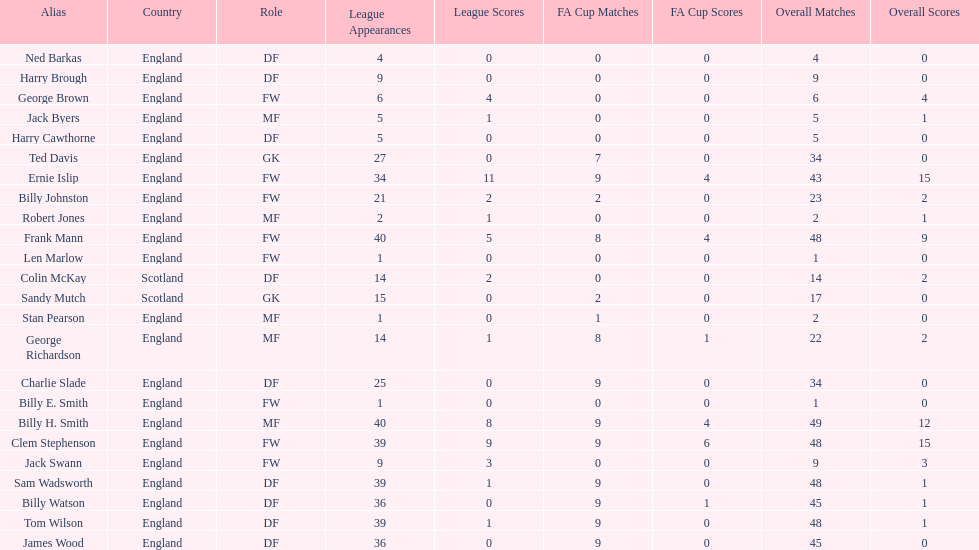How many players are fws? 8. 